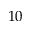<formula> <loc_0><loc_0><loc_500><loc_500>1 0</formula> 